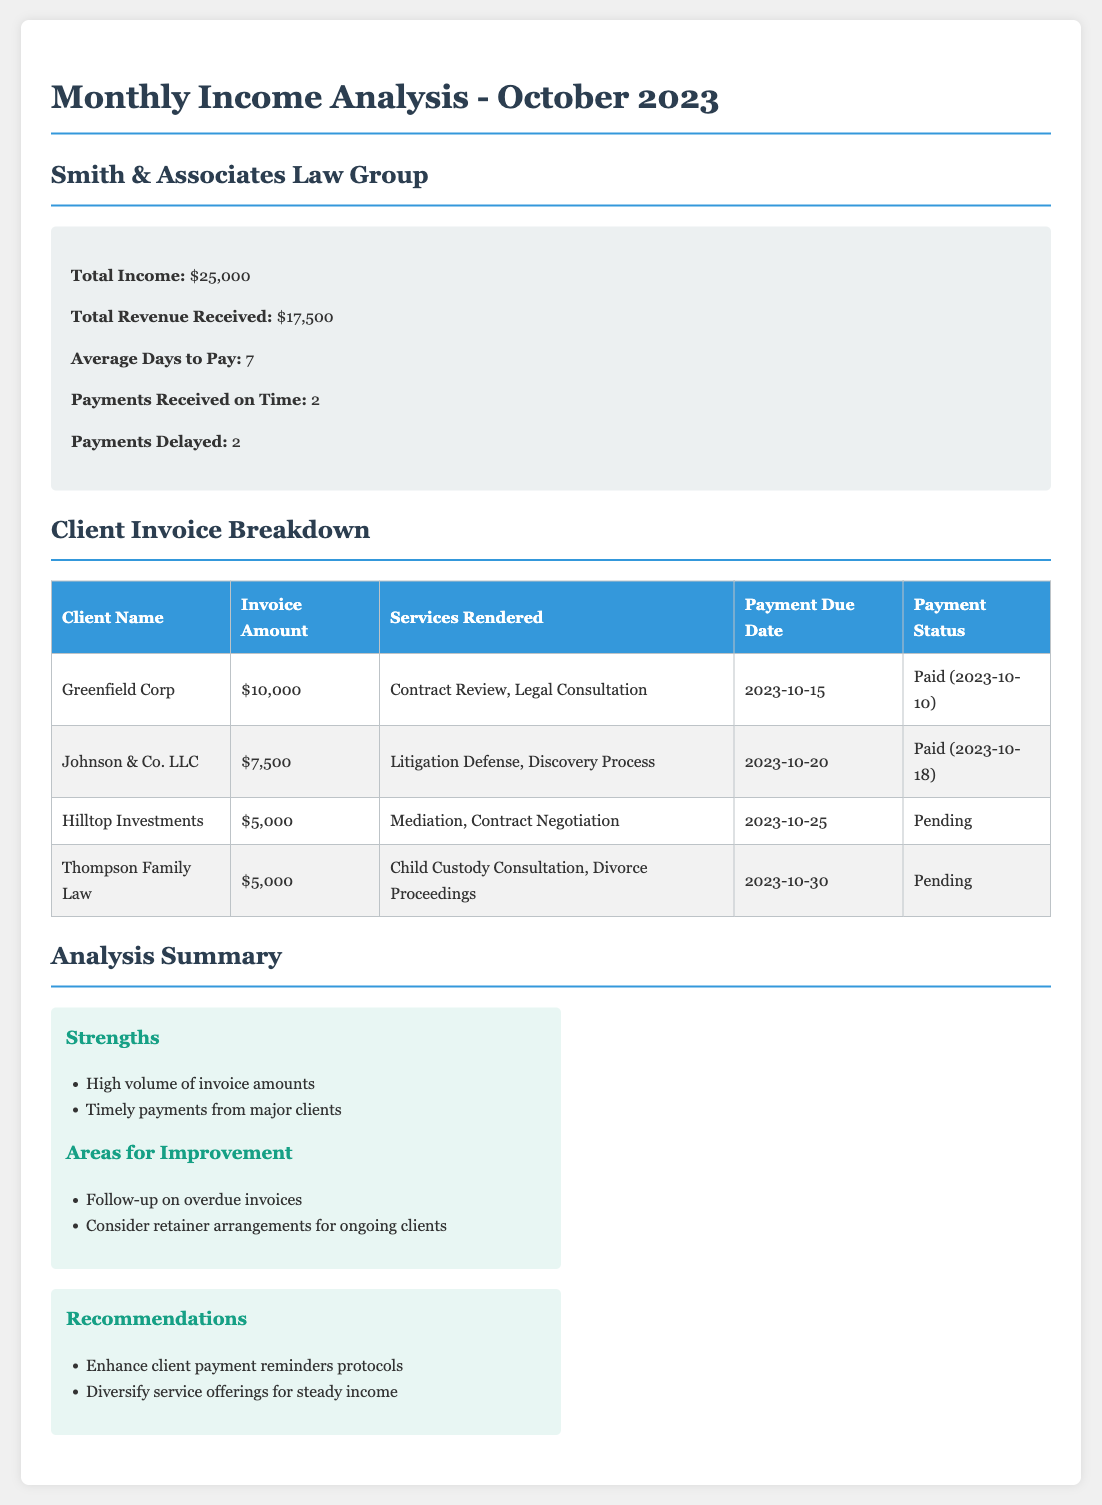what is the total income for October 2023? The total income is provided in the summary section of the document as $25,000.
Answer: $25,000 what is the average days to pay? This information is found in the summary section, indicating the average days to pay is 7.
Answer: 7 how many clients have paid on time? In the summary section, it states that payments received on time total 2.
Answer: 2 what is the invoice amount for Greenfield Corp? The invoice amount for Greenfield Corp is specified in the client invoice breakdown as $10,000.
Answer: $10,000 how many payments are currently pending? The document lists two clients with a pending payment status: Hilltop Investments and Thompson Family Law.
Answer: 2 what is the payment due date for Johnson & Co. LLC? The payment due date for Johnson & Co. LLC is mentioned in the invoice breakdown as 2023-10-20.
Answer: 2023-10-20 what recommendations are made for improving payments? The recommendations include "Enhance client payment reminders protocols" and "Diversify service offerings for steady income."
Answer: Enhance client payment reminders protocols which service was rendered to Hilltop Investments? The services rendered to Hilltop Investments include Mediation and Contract Negotiation, as stated in the invoice breakdown.
Answer: Mediation, Contract Negotiation what are the strengths highlighted in the analysis section? The strengths include "High volume of invoice amounts" and "Timely payments from major clients" listed in the analysis section.
Answer: High volume of invoice amounts what is the payment status for Thompson Family Law? The document describes the payment status for Thompson Family Law as 'Pending'.
Answer: Pending 